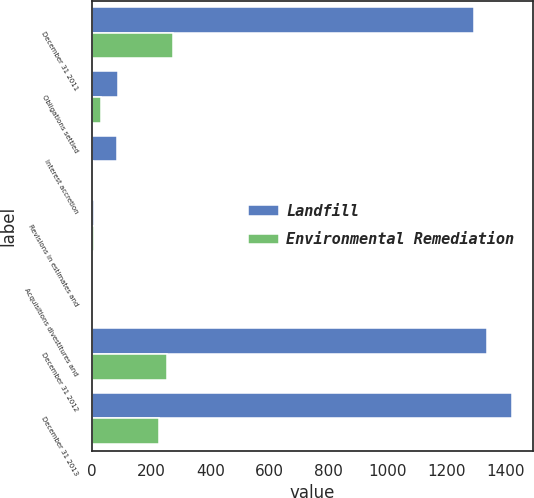<chart> <loc_0><loc_0><loc_500><loc_500><stacked_bar_chart><ecel><fcel>December 31 2011<fcel>Obligations settled<fcel>Interest accretion<fcel>Revisions in estimates and<fcel>Acquisitions divestitures and<fcel>December 31 2012<fcel>December 31 2013<nl><fcel>Landfill<fcel>1292<fcel>87<fcel>84<fcel>8<fcel>1<fcel>1338<fcel>1421<nl><fcel>Environmental Remediation<fcel>273<fcel>30<fcel>4<fcel>5<fcel>1<fcel>253<fcel>227<nl></chart> 